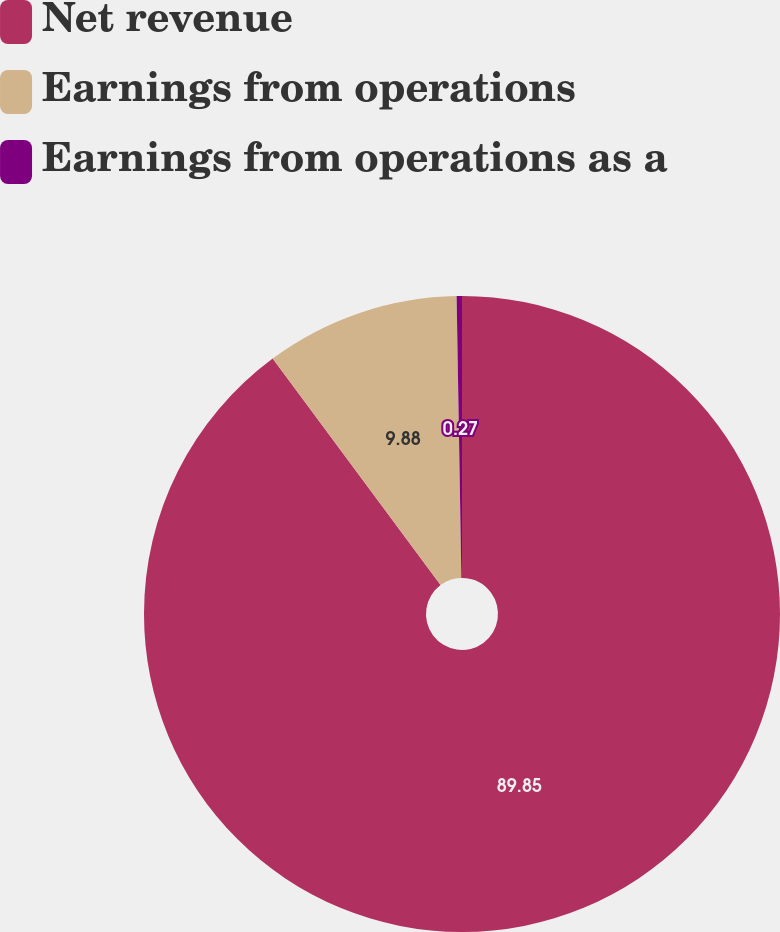Convert chart to OTSL. <chart><loc_0><loc_0><loc_500><loc_500><pie_chart><fcel>Net revenue<fcel>Earnings from operations<fcel>Earnings from operations as a<nl><fcel>89.85%<fcel>9.88%<fcel>0.27%<nl></chart> 